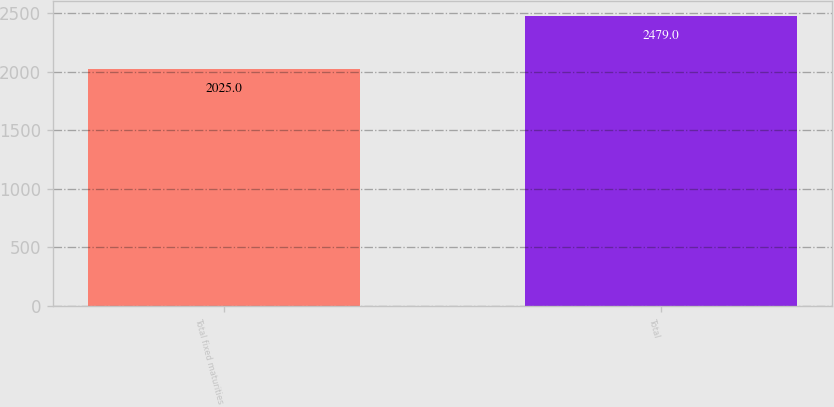<chart> <loc_0><loc_0><loc_500><loc_500><bar_chart><fcel>Total fixed maturities<fcel>Total<nl><fcel>2025<fcel>2479<nl></chart> 